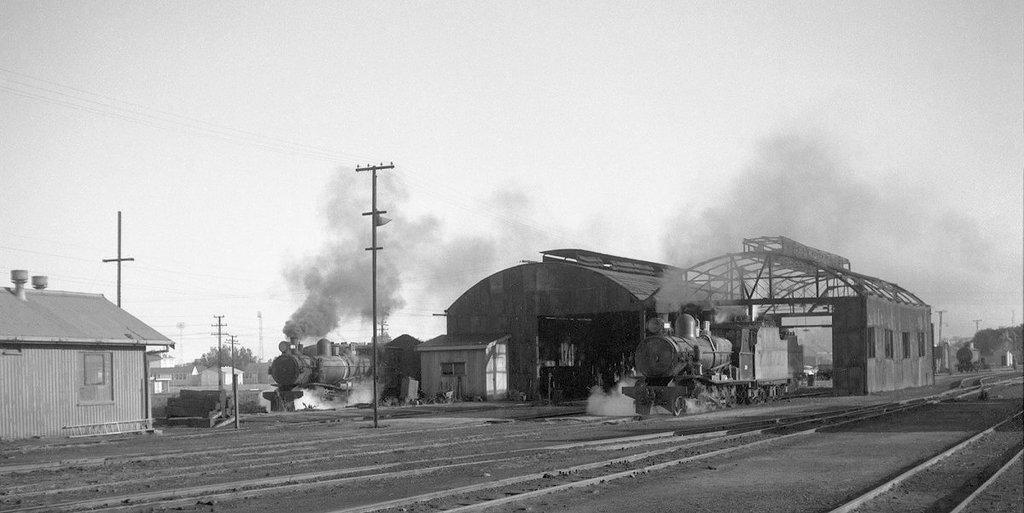How many trains are present in the image? There are two trains on the railway rack in the image. What type of structure can be seen in the image? There is a house in the image. What are the tall, vertical structures in the image? There are electricity poles in the image. What is the purpose of the small, enclosed structure in the image? There is a shed in the image. What is the visible emission in the image? There is smoke visible in the image. What is the color scheme of the image? The image is black and white. What type of natural vegetation is present in the image? There are trees in the image. What type of carriage is being pulled by the horses in the image? There are no horses or carriages present in the image; it features two trains on a railway rack. What work is being done by the people in the image? The image does not depict any people or work being done. 